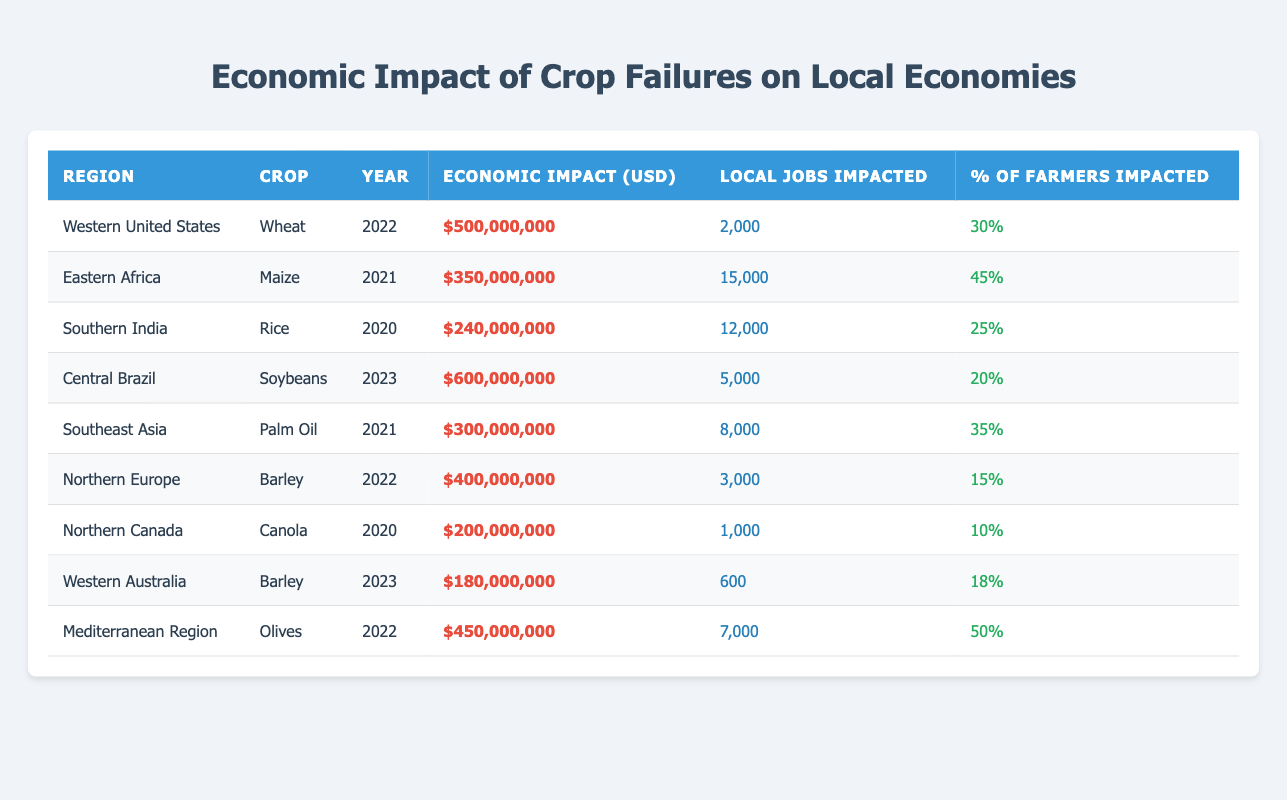What was the economic impact of crop failures in Eastern Africa in 2021? The table directly states that the economic impact in Eastern Africa for maize in 2021 was $350,000,000.
Answer: $350,000,000 Which region had the highest economic impact from crop failures and what was the amount? By comparing the economic impact values listed, Central Brazil had the highest economic impact from crop failures, amounting to $600,000,000.
Answer: Central Brazil, $600,000,000 How many local jobs were impacted by crop failures in the Mediterranean region in 2022? The table indicates that the number of local jobs impacted in the Mediterranean region for olives in 2022 was 7,000.
Answer: 7,000 What percentage of farmers were impacted in Southern India and Eastern Africa? Southern India had 25% of farmers impacted, while Eastern Africa had 45% impacted.
Answer: 25% (Southern India), 45% (Eastern Africa) Which crop failure in 2020 had the lowest economic impact? By comparing the amounts for the year 2020, the lowest economic impact was from Northern Canada, amounting to $200,000,000 for canola.
Answer: Northern Canada, $200,000,000 What is the total economic impact across all regions for the year 2022? To find the total economic impact for 2022, we sum the amounts for that year: $500,000,000 (Western United States) + $400,000,000 (Northern Europe) + $450,000,000 (Mediterranean Region) = $1,350,000,000.
Answer: $1,350,000,000 Did any crop failure in 2023 impact more than 5,000 local jobs? In 2023, only the crop failure in Central Brazil had 5,000 jobs impacted, while Western Australia had 600 jobs. Therefore, no crop failure in 2023 impacted more than 5,000 jobs.
Answer: No Which region experienced the largest percentage of farmers impacted by crop failures, and what was that percentage? By examining the percentages, the Mediterranean Region had the largest impact on farmers at 50%.
Answer: Mediterranean Region, 50% How do the local jobs impacted in the Eastern Africa crop failure compare to those in Northern Europe? Eastern Africa had 15,000 local jobs impacted while Northern Europe had 3,000 jobs, clearly indicating that Eastern Africa had significantly more jobs impacted. The difference is 15,000 - 3,000 = 12,000.
Answer: Eastern Africa, 12,000 more jobs What is the average percentage of farmers impacted across all regions listed for crop failures? The percentages of farmers impacted are 30%, 45%, 25%, 20%, 35%, 15%, 10%, 18%, and 50%. To get the average: (30 + 45 + 25 + 20 + 35 + 15 + 10 + 18 + 50) / 9 = 30.
Answer: 30% 